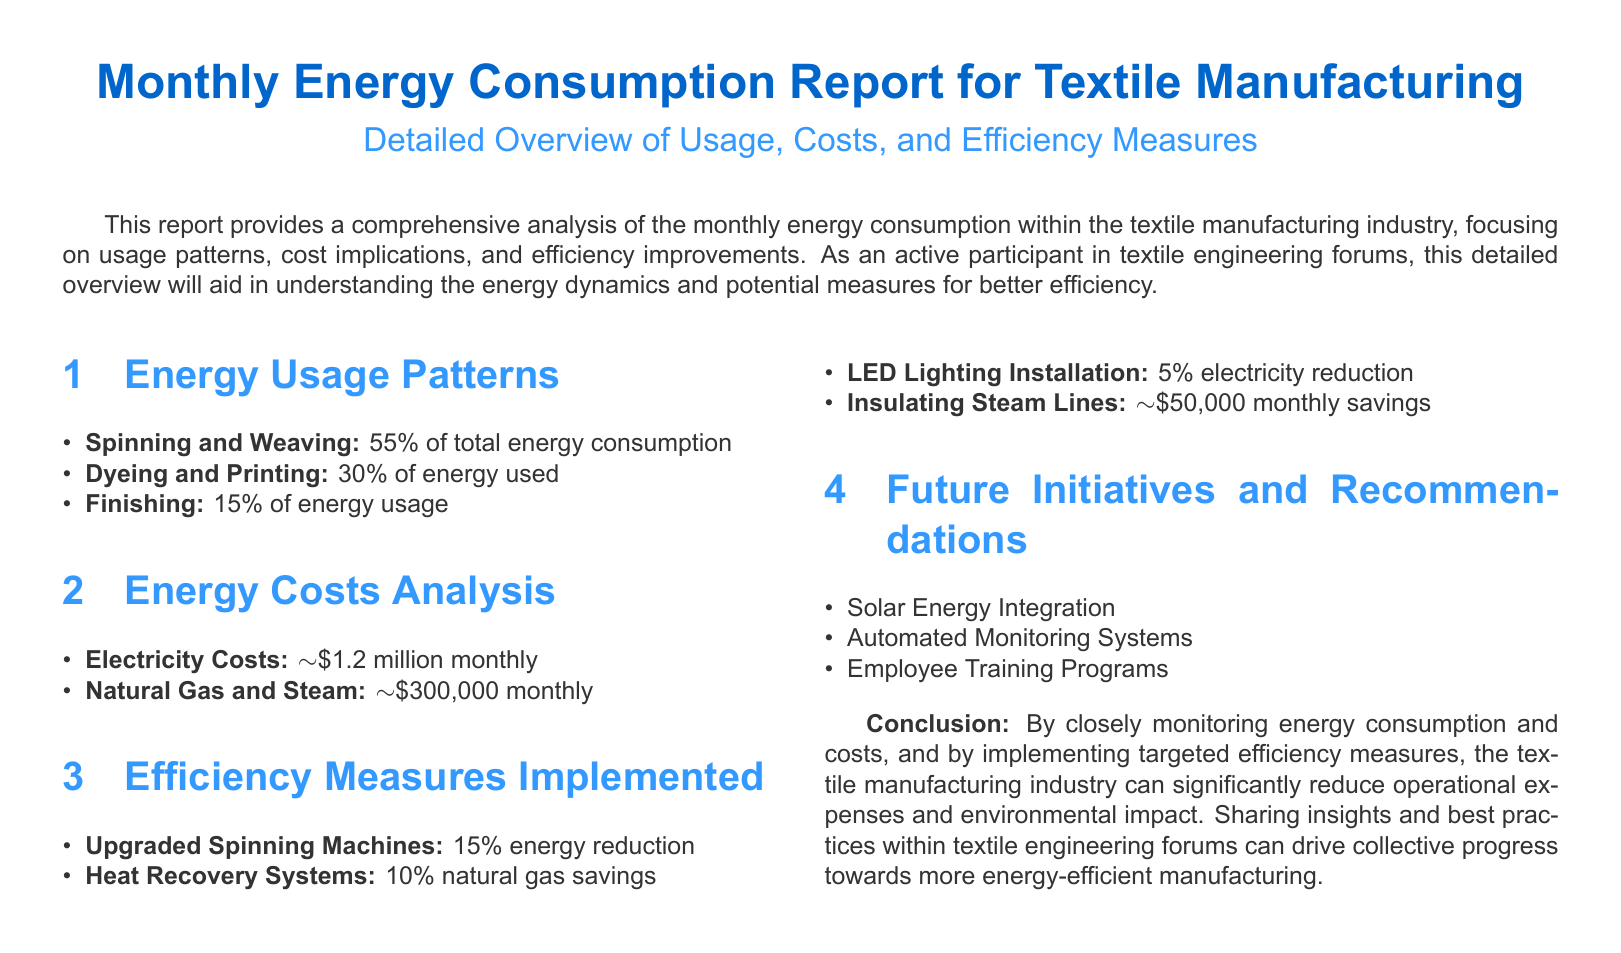what percentage of total energy consumption is from spinning and weaving? The document states that spinning and weaving account for 55% of total energy consumption.
Answer: 55% what is the monthly electricity cost reported? The report mentions the electricity costs as approximately $1.2 million monthly.
Answer: $1.2 million which efficiency measure results in the highest percentage of energy reduction? The document indicates that upgraded spinning machines lead to a 15% energy reduction.
Answer: 15% what future initiative is listed for solar energy? The report mentions solar energy integration as a future initiative.
Answer: Solar Energy Integration how much can be saved monthly by insulating steam lines? The document states that insulating steam lines can lead to approximately $50,000 in monthly savings.
Answer: $50,000 what is the total percentage of energy consumption from dyeing and printing? The reported energy consumption from dyeing and printing is 30%.
Answer: 30% how much is spent monthly on natural gas and steam? The document specifies the expenditure on natural gas and steam as approximately $300,000 monthly.
Answer: $300,000 what is one of the efficiency measures that results in natural gas savings? The document mentions heat recovery systems as a measure that offers natural gas savings.
Answer: Heat Recovery Systems what training program is recommended in the future initiatives? The report lists employee training programs as a recommended future initiative.
Answer: Employee Training Programs 